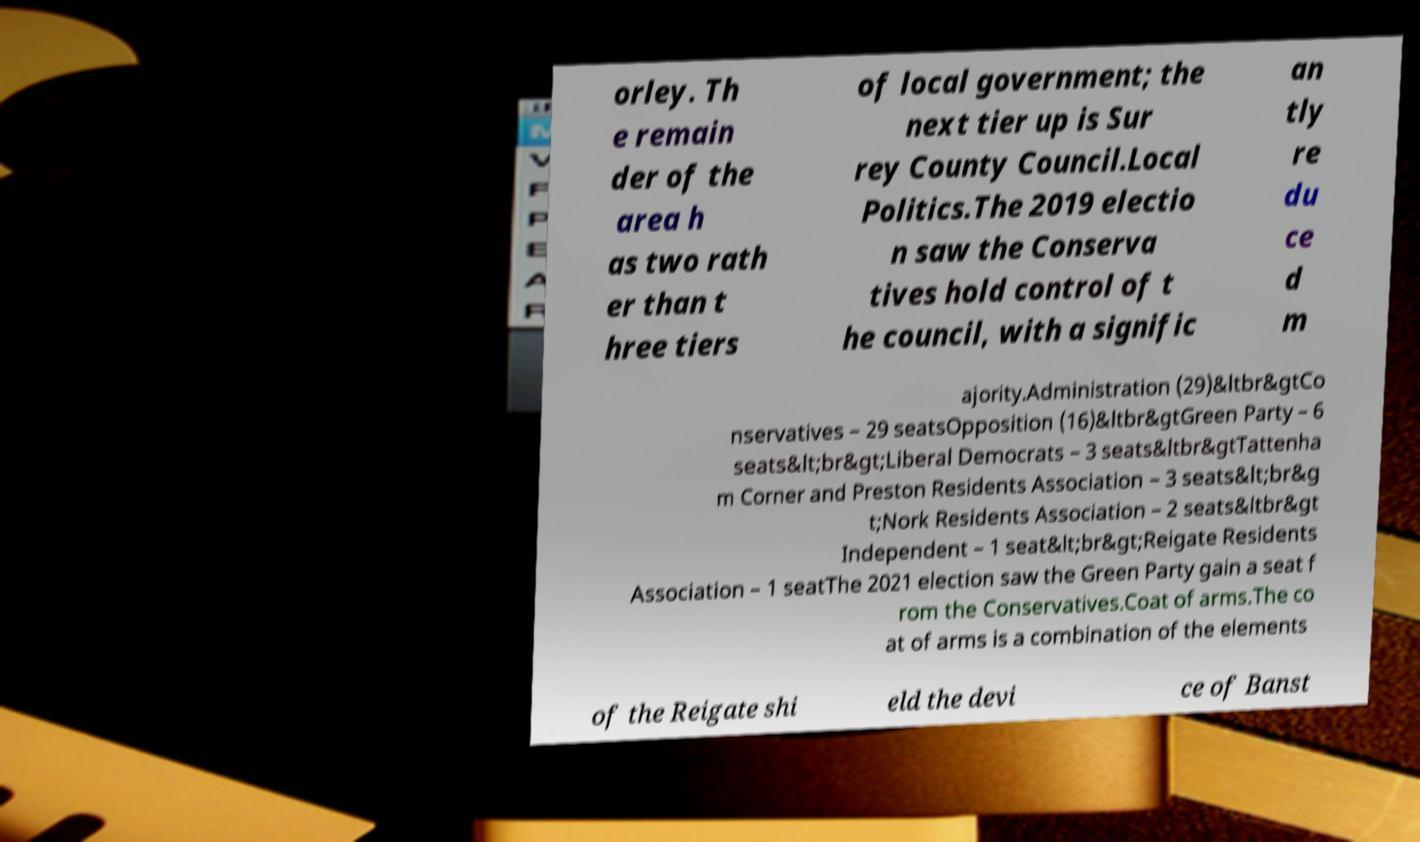Could you extract and type out the text from this image? orley. Th e remain der of the area h as two rath er than t hree tiers of local government; the next tier up is Sur rey County Council.Local Politics.The 2019 electio n saw the Conserva tives hold control of t he council, with a signific an tly re du ce d m ajority.Administration (29)&ltbr&gtCo nservatives – 29 seatsOpposition (16)&ltbr&gtGreen Party – 6 seats&lt;br&gt;Liberal Democrats – 3 seats&ltbr&gtTattenha m Corner and Preston Residents Association – 3 seats&lt;br&g t;Nork Residents Association – 2 seats&ltbr&gt Independent – 1 seat&lt;br&gt;Reigate Residents Association – 1 seatThe 2021 election saw the Green Party gain a seat f rom the Conservatives.Coat of arms.The co at of arms is a combination of the elements of the Reigate shi eld the devi ce of Banst 